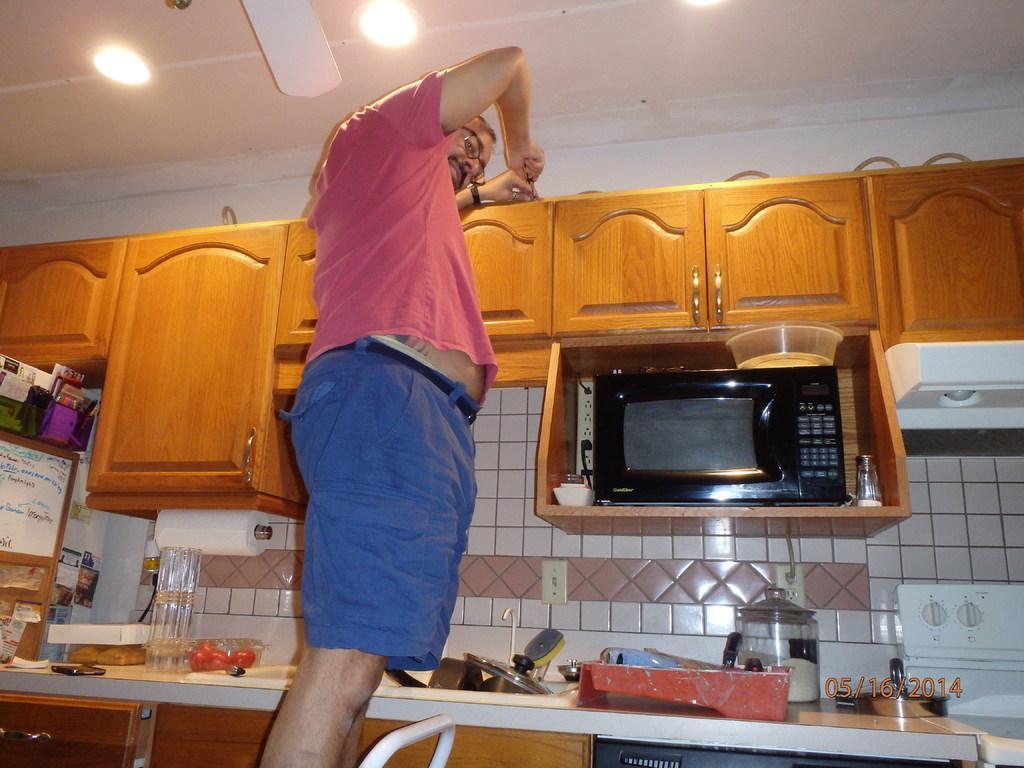Can you describe this image briefly? In this picture there is a man wearing pink color t-shirt and blue shorts standing and repairing the wooden cabinet door. Below there is a black color micro oven in the box and some white color cladding tiles. In the front bottom side there is a kitchen platform with some red color plastic tray and some vessels are placed on it. 